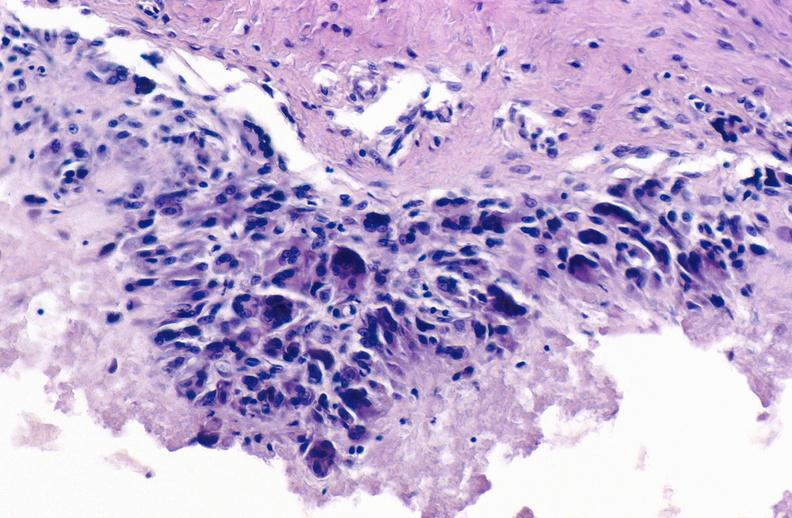s aorta not present?
Answer the question using a single word or phrase. No 